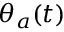<formula> <loc_0><loc_0><loc_500><loc_500>\theta _ { a } ( t )</formula> 